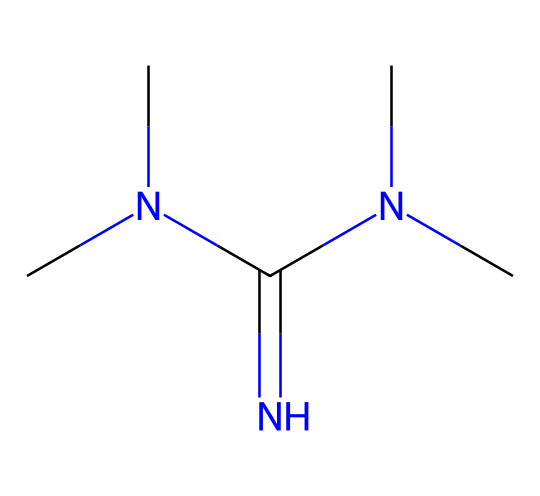What is the name of this chemical? The SMILES representation indicates a compound known as tetramethylguanidine, which is characterized by its four methyl groups attached to the guanidine structure.
Answer: tetramethylguanidine How many nitrogen atoms are present in this chemical? By examining the structure in the SMILES, we can identify three nitrogen atoms in the guanidine moiety indicated in the representation.
Answer: three What type of base is tetramethylguanidine classified as? Tetramethylguanidine is classified as a superbase, known for its exceptionally high basicity compared to conventional bases like sodium hydroxide.
Answer: superbase What is the total number of carbon atoms in the molecule? The SMILES notation shows four carbon atoms, as deduced from the four methyl groups (each contributing one carbon) and the guanidine's carbon atom.
Answer: four Considering its structure, why is tetramethylguanidine effective in low-VOC paints? It has a strong basic character due to the presence of nitrogen atoms, which enhance its ability to neutralize acidity in paint formulations and improve the stability of the paint while remaining low in volatile organic compounds.
Answer: strong basic character How many hydrogen atoms are connected to carbon in the molecular structure? Each carbon atom in the four methyl groups is attached to three hydrogen atoms, totaling twelve hydrogen atoms from the methyl groups, with one different hydrogen from the center carbon in guanidine leading to a total of thirteen.
Answer: thirteen 